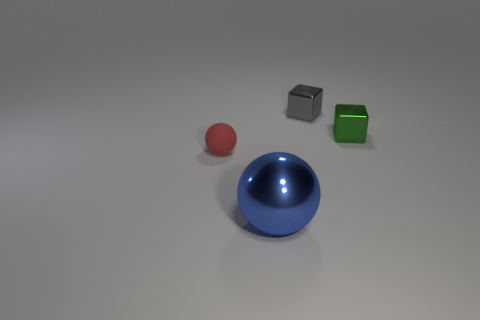How many red balls are on the left side of the ball in front of the tiny matte sphere?
Your answer should be very brief. 1. There is another metal object that is the same shape as the gray object; what color is it?
Ensure brevity in your answer.  Green. Are the large thing and the red ball made of the same material?
Make the answer very short. No. What number of balls are either big green rubber things or matte objects?
Keep it short and to the point. 1. How big is the ball that is left of the metallic object that is in front of the sphere on the left side of the large ball?
Offer a terse response. Small. There is a blue metal object that is the same shape as the rubber object; what size is it?
Ensure brevity in your answer.  Large. There is a tiny red matte ball; what number of blue spheres are in front of it?
Offer a very short reply. 1. There is a object that is in front of the small red ball; is its color the same as the tiny rubber thing?
Keep it short and to the point. No. What number of green objects are rubber spheres or big cylinders?
Make the answer very short. 0. The sphere that is behind the sphere that is on the right side of the tiny red rubber thing is what color?
Your answer should be compact. Red. 